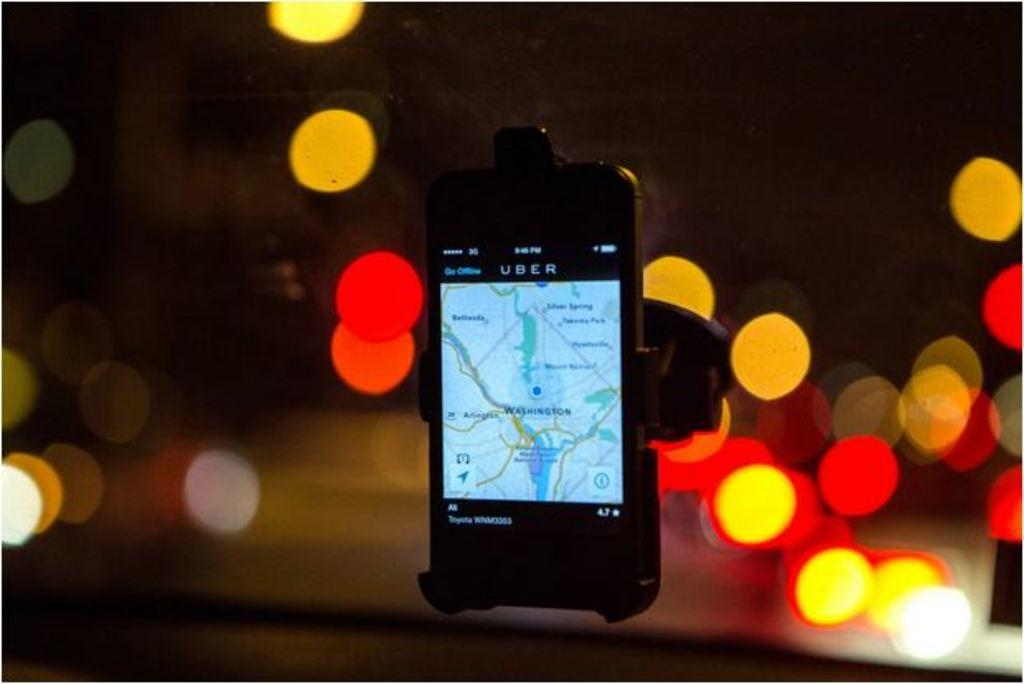<image>
Render a clear and concise summary of the photo. A phone displaying the UBER app is stuck to a car window. 